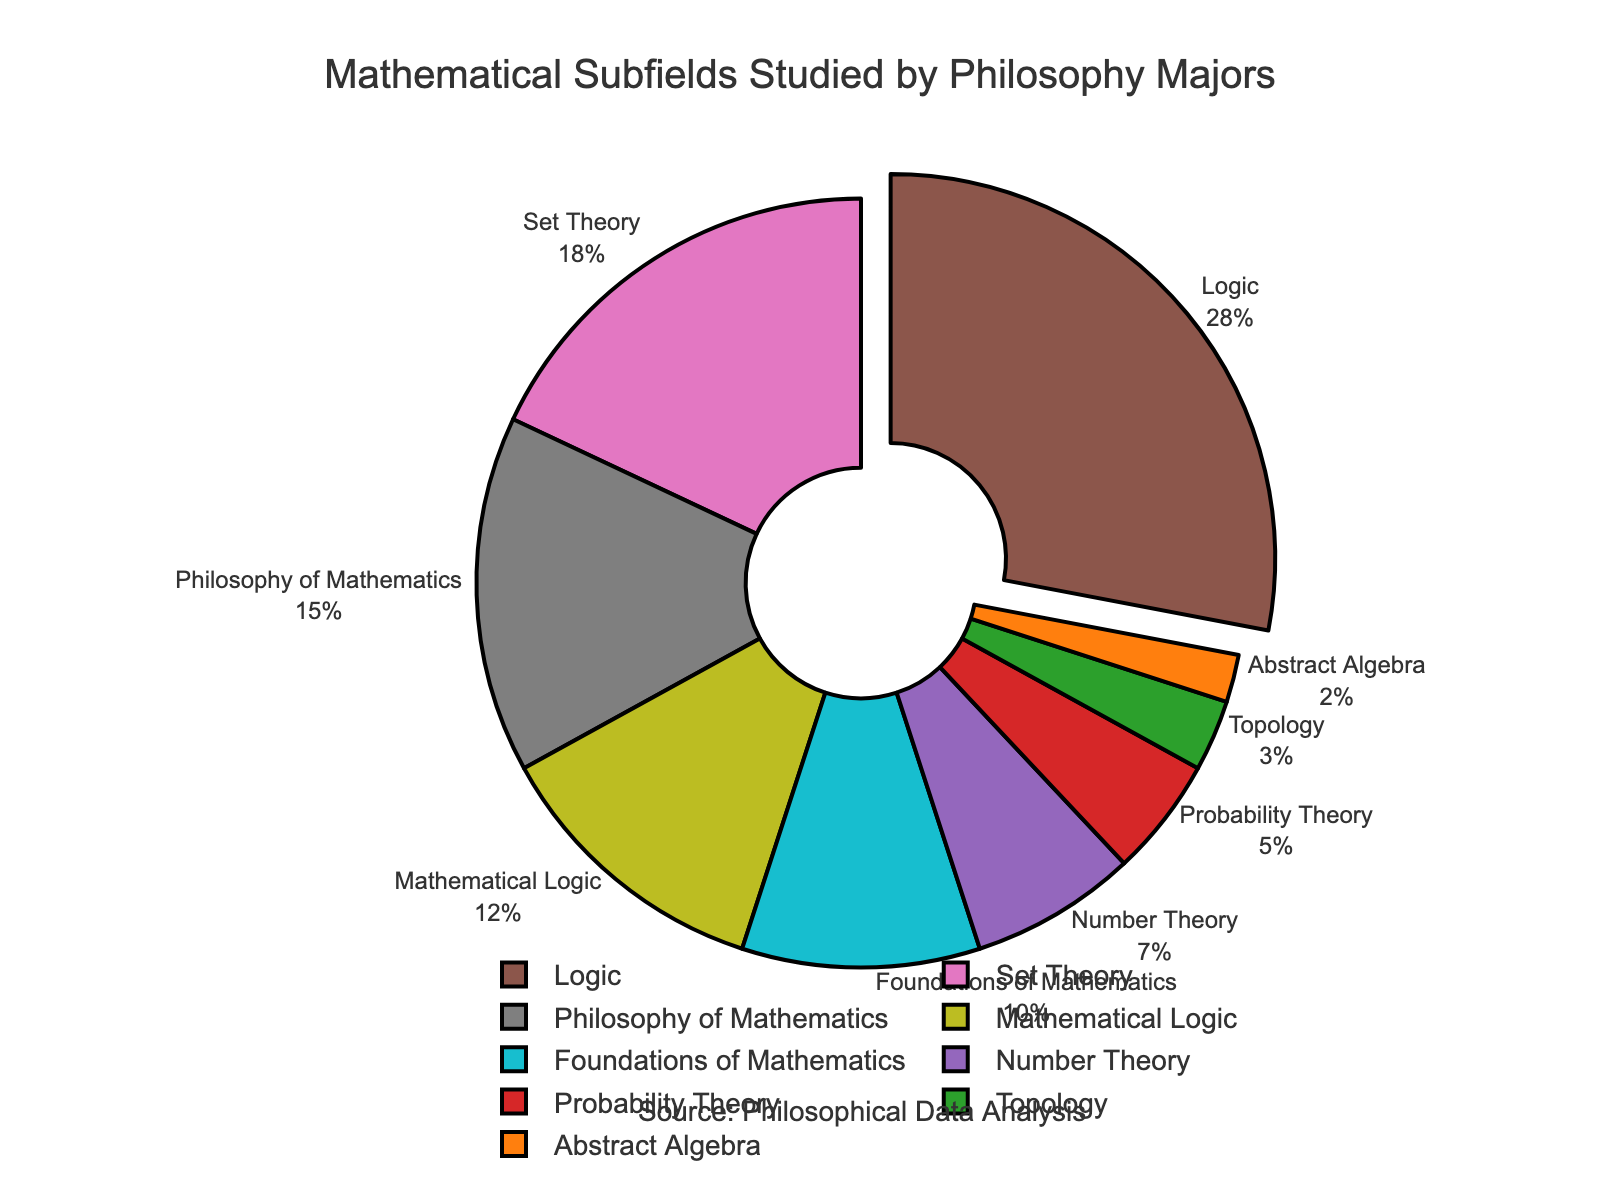What's the largest subfield studied by philosophy majors and what is its percentage? The largest subfield can be identified by looking at the segment of the pie chart that stands out the most or is pulled out. This subfield is labeled "Logic" with a percentage of 28%.
Answer: Logic, 28% What's the combined percentage of Set Theory and Number Theory? Find the percentages associated with Set Theory and Number Theory from the chart. Set Theory has 18%, and Number Theory has 7%. Adding these together gives 18% + 7% = 25%.
Answer: 25% Compare the percentage of Mathematical Logic with Probability Theory. Which is higher and by how much? Identify the percentages for Mathematical Logic (12%) and Probability Theory (5%). Subtract the percentage of Probability Theory from Mathematical Logic: 12% - 5% = 7%. Mathematical Logic is higher by 7%.
Answer: Mathematical Logic, 7% Which subfield has the second smallest percentage and what is it? Sort the subfields by their percentages in ascending order. The second smallest percentage after Abstract Algebra (2%) is Topology (3%).
Answer: Topology, 3% What are the colors used for the three largest subfields? Identify the three largest subfields: Logic (28%), Set Theory (18%), and Philosophy of Mathematics (15%). Locate their corresponding colors on the pie chart. Logic is brown, Set Theory is pink, and Philosophy of Mathematics is grey.
Answer: Brown, Pink, Grey What is the total percentage covered by the categories other than the top three largest subfields? Find the percentages of all subfields except Logic (28%), Set Theory (18%), and Philosophy of Mathematics (15%). The remaining subfields are Mathematical Logic (12%), Foundations of Mathematics (10%), Number Theory (7%), Probability Theory (5%), Topology (3%), and Abstract Algebra (2%). Adding these together: 12% + 10% + 7% + 5% + 3% + 2% = 39%.
Answer: 39% Which subfield is represented with the color green, and what is its percentage? Locate the green segment on the pie chart and identify the corresponding subfield and its percentage. The green segment represents Probability Theory, which is 5%.
Answer: Probability Theory, 5% How does the percentage of Foundations of Mathematics compare to that of Probability Theory? Identify the percentage of Foundations of Mathematics (10%) and compare it to Probability Theory (5%). Foundations of Mathematics is higher by 10% - 5% = 5%.
Answer: Foundations of Mathematics, 5% What is the combined percentage of all subfields related to logic and foundations? Add the percentages of Logic (28%), Mathematical Logic (12%), and Foundations of Mathematics (10%). 28% + 12% + 10% = 50%.
Answer: 50% Which subfield has a smaller percentage: Abstract Algebra or Topology, and by how much? Identify the percentages for Abstract Algebra (2%) and Topology (3%). Subtract the percentage of Abstract Algebra from Topology: 3% - 2% = 1%. Abstract Algebra is smaller by 1%.
Answer: Abstract Algebra, 1% 